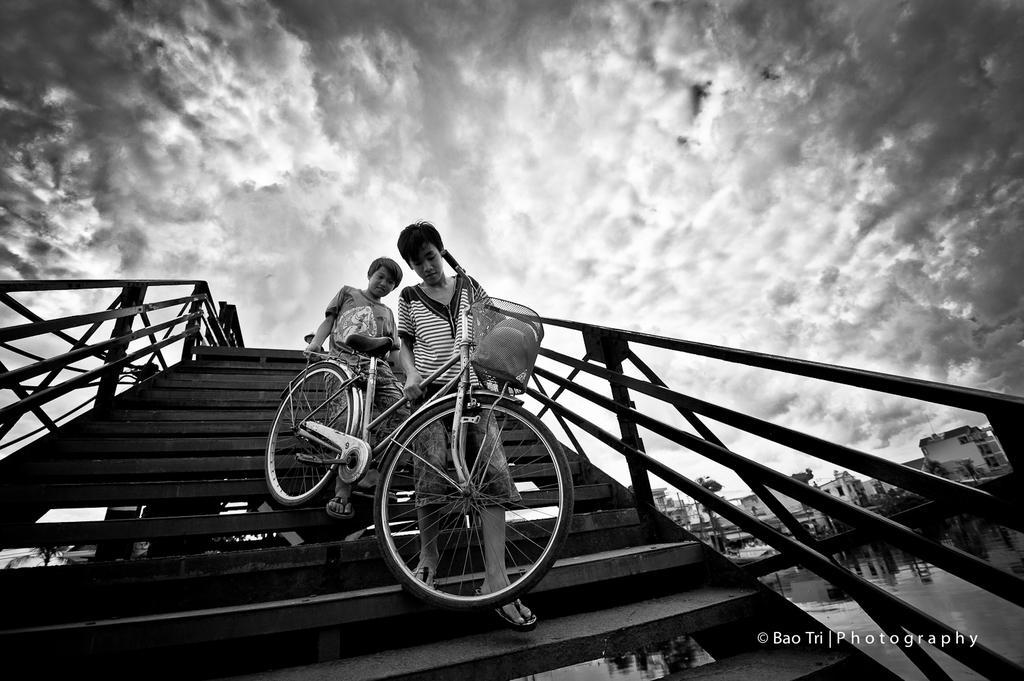Please provide a concise description of this image. This looks like a black and white image. I can see two boys carrying a bicycle and walking down the stairs. These are the staircase holders. On the right side of the image, I can see the buildings. These are the clouds in the sky. At the bottom of the image, that looks like the watermark. 